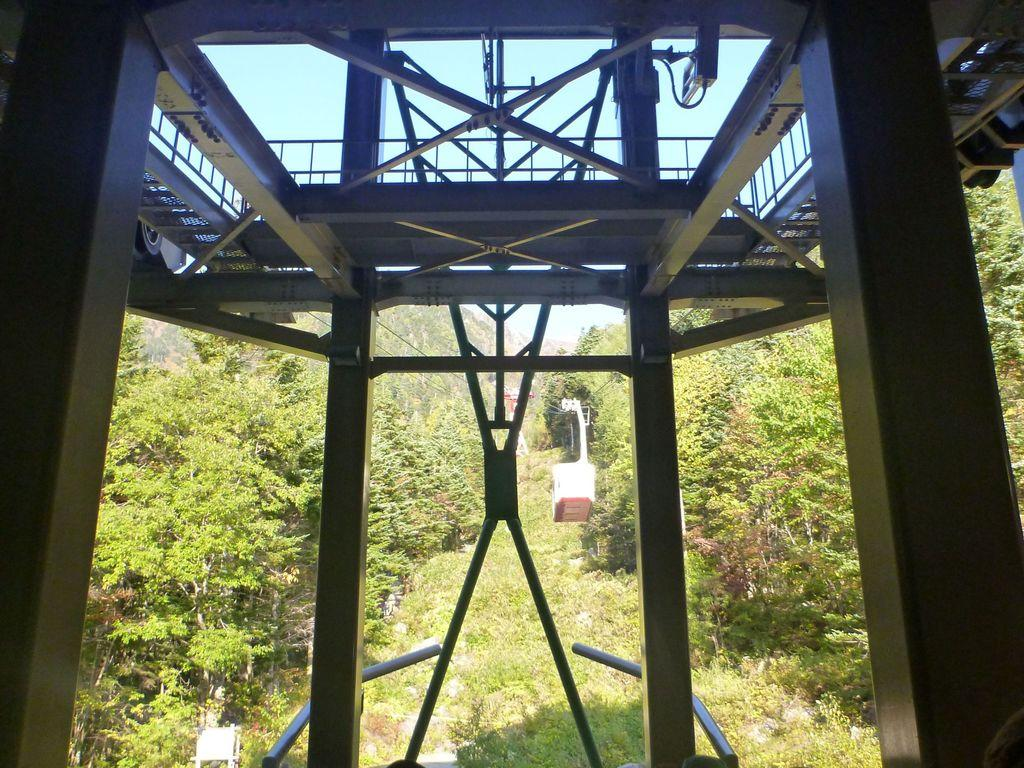What type of vegetation can be seen on both sides of the image? There are trees on both the right and left sides of the image. What type of ground cover is visible at the bottom of the image? There is grass at the bottom of the image. What is visible at the top of the image? The sky is visible at the top of the image. What type of material is present in the image? There are metal rods in the image. What type of crime is being committed in the image? There is no crime present in the image; it features trees, grass, sky, and metal rods. How does the baby contribute to the rhythm of the image? There is no baby present in the image, so it cannot contribute to any rhythm. 